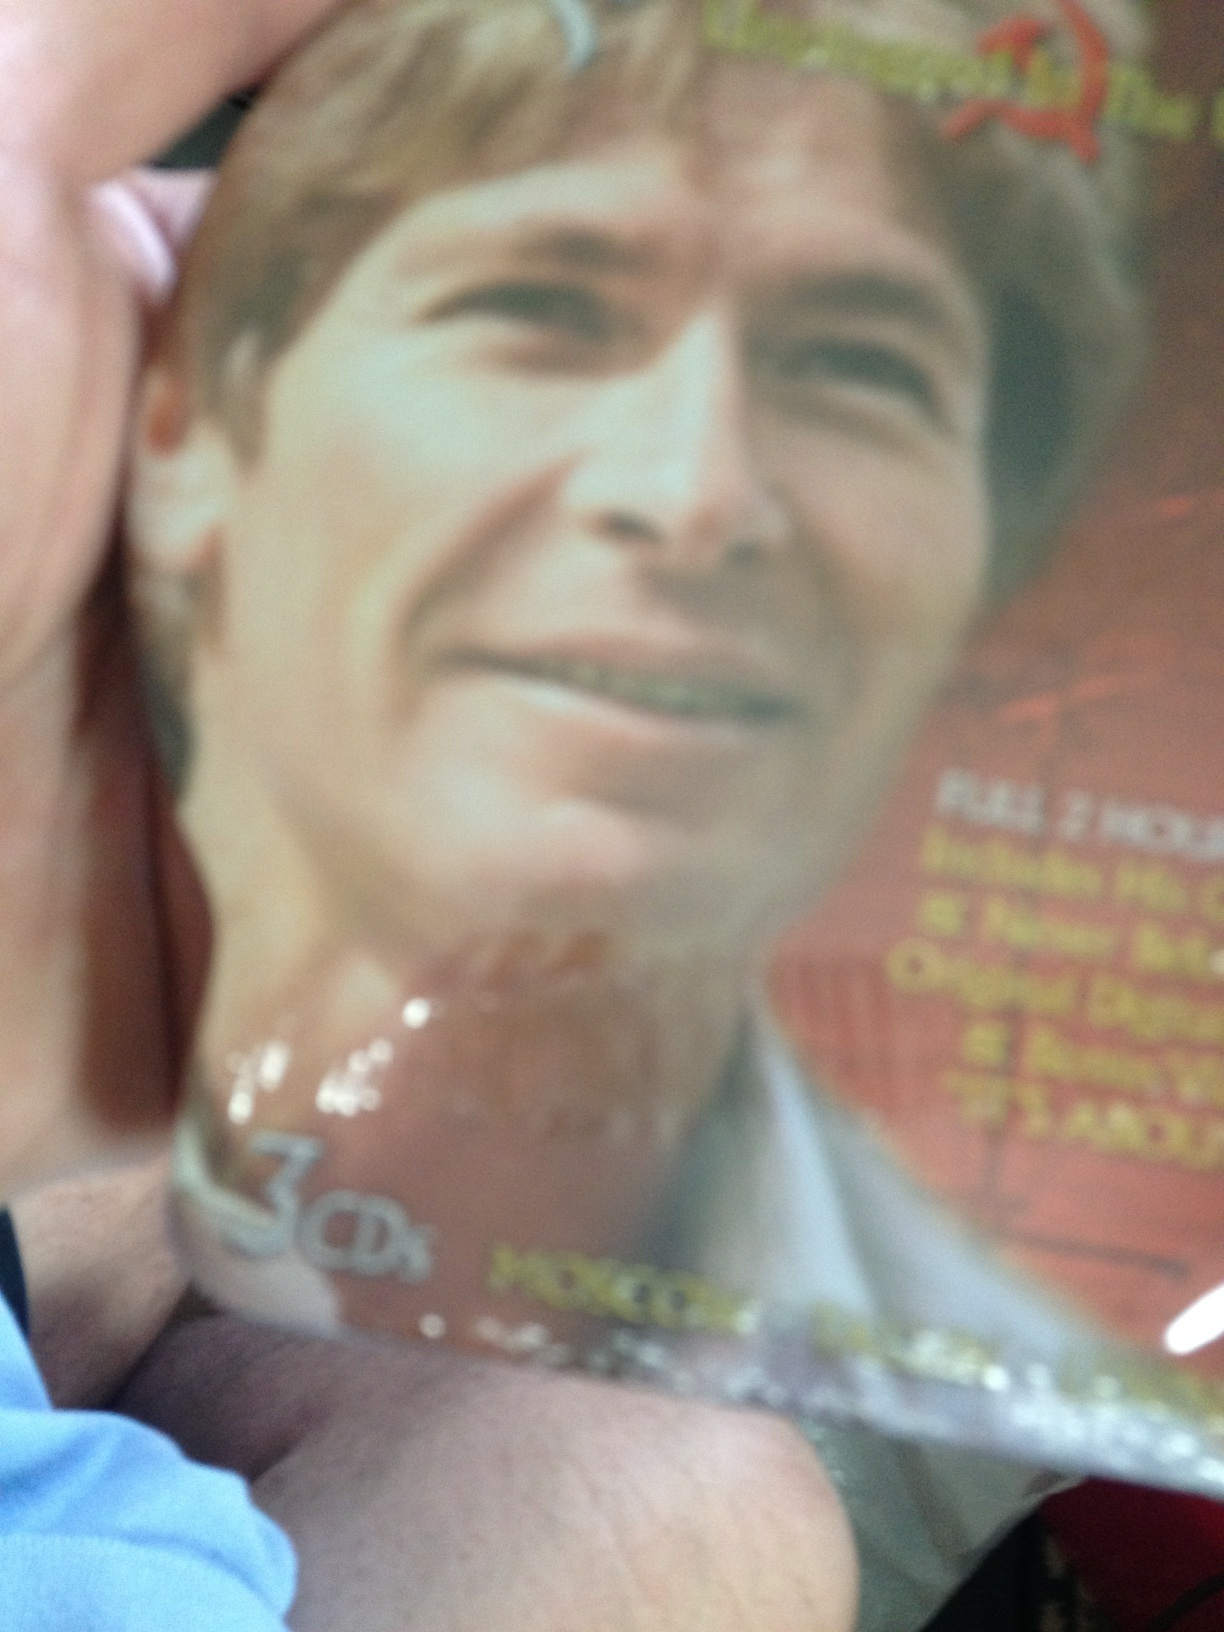If this CD were to be a soundtrack for a movie, what kind of movie would it be? This CD could be a soundtrack for a dramatic, heartfelt movie exploring themes of love, loss, and redemption. The film might follow the life of the artist portrayed on the cover, chronicling his rise to fame, personal struggles, and ultimate triumphs. It would be a deeply emotional and inspiring narrative. Could this CD be a live performance recording? Why or why not? It's possible that this CD could be a live performance recording. The presence of multiple CDs suggests there could be a comprehensive collection of live performances, capturing the energy and interaction of the artist with the audience over several shows or a tour. 